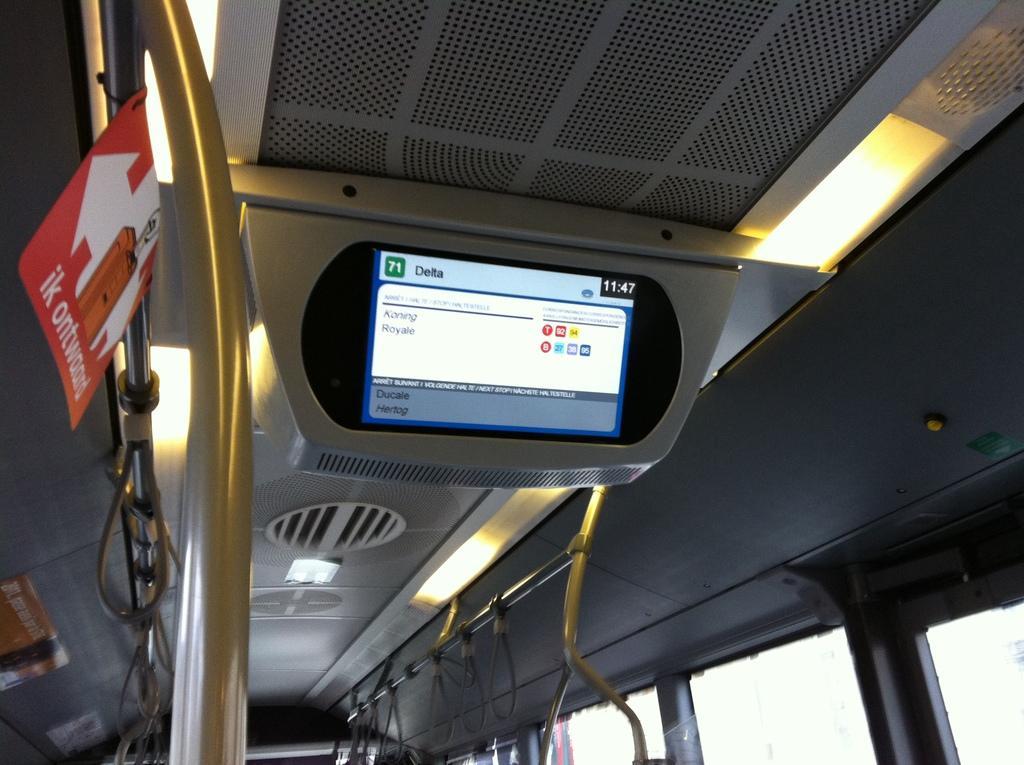Could you give a brief overview of what you see in this image? In this image I can see the inner part of the vehicle. I can see few windows, screen, lights, board and few bus handles attached to the poles. 